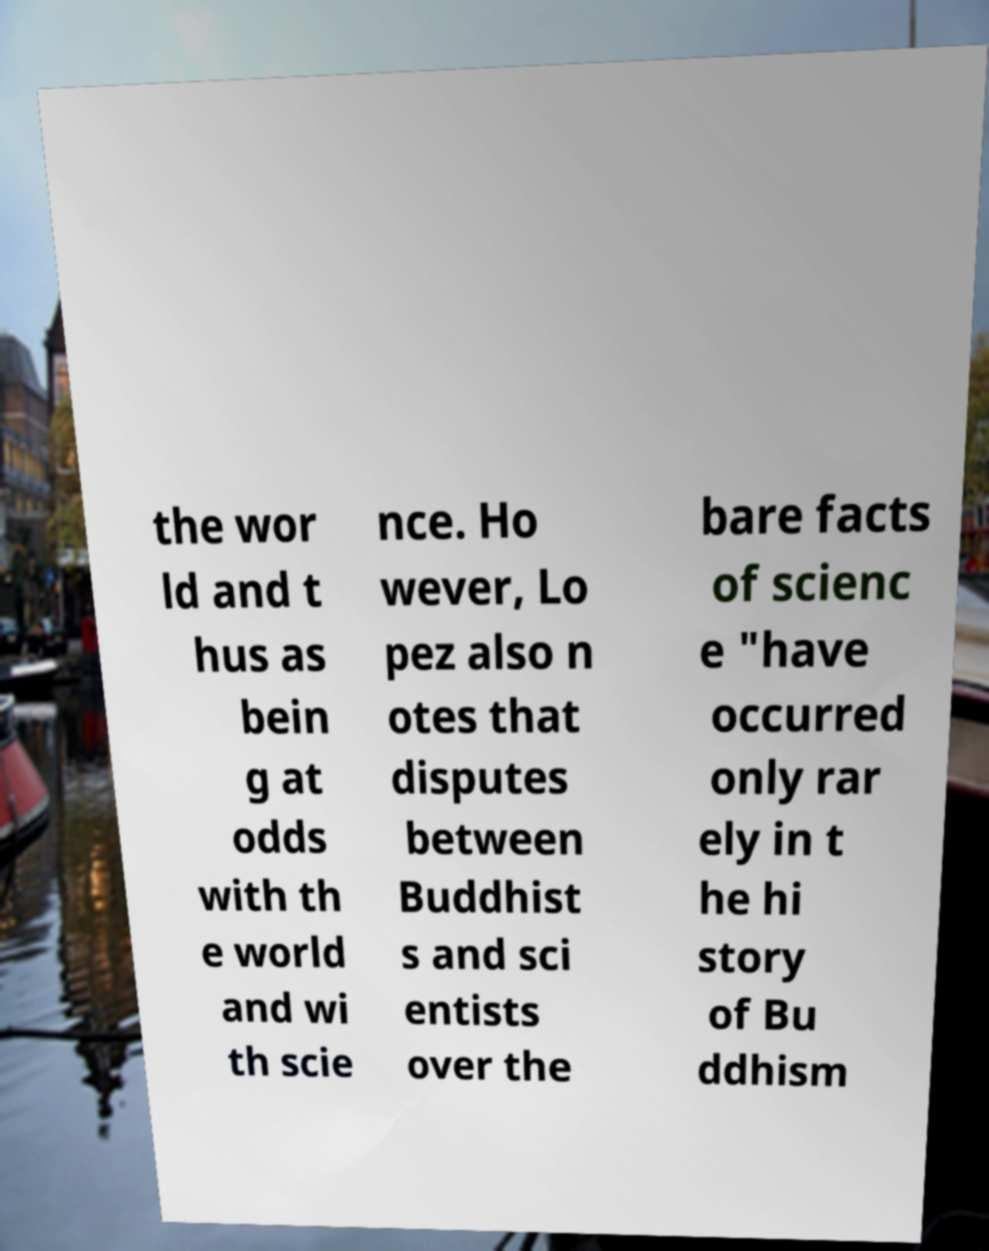Could you extract and type out the text from this image? the wor ld and t hus as bein g at odds with th e world and wi th scie nce. Ho wever, Lo pez also n otes that disputes between Buddhist s and sci entists over the bare facts of scienc e "have occurred only rar ely in t he hi story of Bu ddhism 